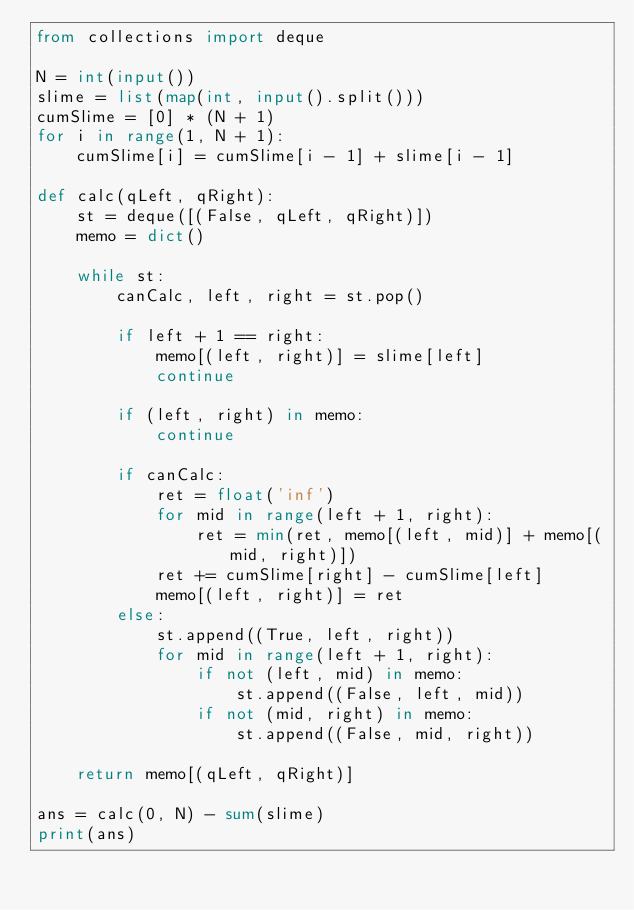<code> <loc_0><loc_0><loc_500><loc_500><_Python_>from collections import deque

N = int(input())
slime = list(map(int, input().split()))
cumSlime = [0] * (N + 1)
for i in range(1, N + 1):
    cumSlime[i] = cumSlime[i - 1] + slime[i - 1]

def calc(qLeft, qRight):
    st = deque([(False, qLeft, qRight)])
    memo = dict()

    while st:
        canCalc, left, right = st.pop()

        if left + 1 == right:
            memo[(left, right)] = slime[left]
            continue

        if (left, right) in memo:
            continue

        if canCalc:
            ret = float('inf')
            for mid in range(left + 1, right):
                ret = min(ret, memo[(left, mid)] + memo[(mid, right)])
            ret += cumSlime[right] - cumSlime[left]
            memo[(left, right)] = ret
        else:
            st.append((True, left, right))
            for mid in range(left + 1, right):
                if not (left, mid) in memo:
                    st.append((False, left, mid))
                if not (mid, right) in memo:
                    st.append((False, mid, right))

    return memo[(qLeft, qRight)]

ans = calc(0, N) - sum(slime)
print(ans)</code> 